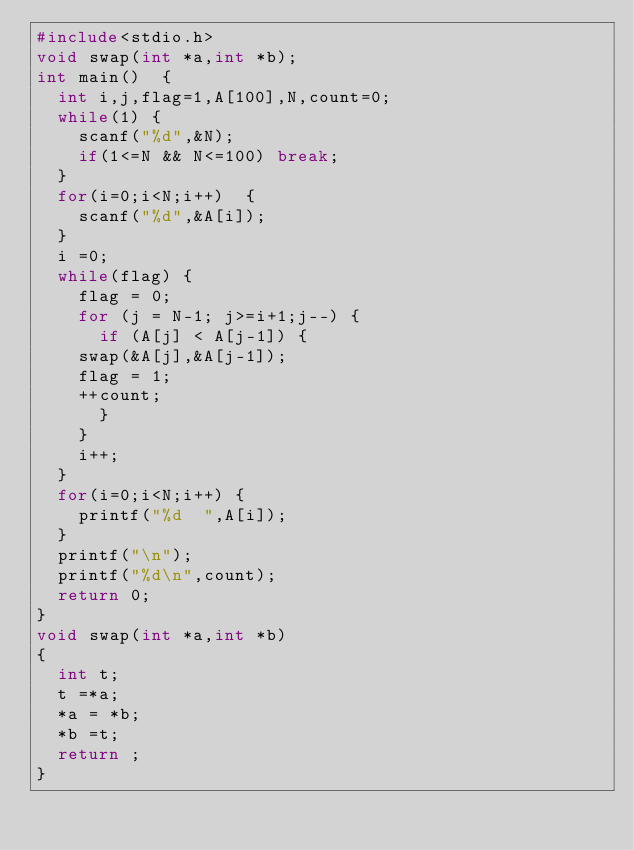Convert code to text. <code><loc_0><loc_0><loc_500><loc_500><_C_>#include<stdio.h>
void swap(int *a,int *b);
int main()  {
  int i,j,flag=1,A[100],N,count=0;
  while(1) {
    scanf("%d",&N);
    if(1<=N && N<=100) break;
  }
  for(i=0;i<N;i++)  {
    scanf("%d",&A[i]);
  }
  i =0;
  while(flag) {
    flag = 0;
    for (j = N-1; j>=i+1;j--) {
      if (A[j] < A[j-1]) {
	swap(&A[j],&A[j-1]);
	flag = 1;
	++count;
      }
    }
    i++;
  }
  for(i=0;i<N;i++) {
    printf("%d  ",A[i]);
  }
  printf("\n");
  printf("%d\n",count);
  return 0;
}
void swap(int *a,int *b)
{
  int t;
  t =*a;
  *a = *b;
  *b =t;
  return ;
}</code> 